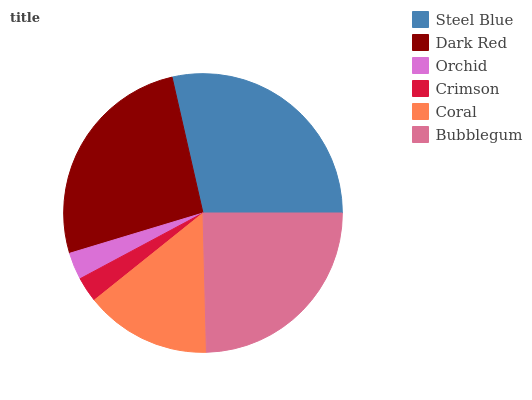Is Crimson the minimum?
Answer yes or no. Yes. Is Steel Blue the maximum?
Answer yes or no. Yes. Is Dark Red the minimum?
Answer yes or no. No. Is Dark Red the maximum?
Answer yes or no. No. Is Steel Blue greater than Dark Red?
Answer yes or no. Yes. Is Dark Red less than Steel Blue?
Answer yes or no. Yes. Is Dark Red greater than Steel Blue?
Answer yes or no. No. Is Steel Blue less than Dark Red?
Answer yes or no. No. Is Bubblegum the high median?
Answer yes or no. Yes. Is Coral the low median?
Answer yes or no. Yes. Is Crimson the high median?
Answer yes or no. No. Is Bubblegum the low median?
Answer yes or no. No. 